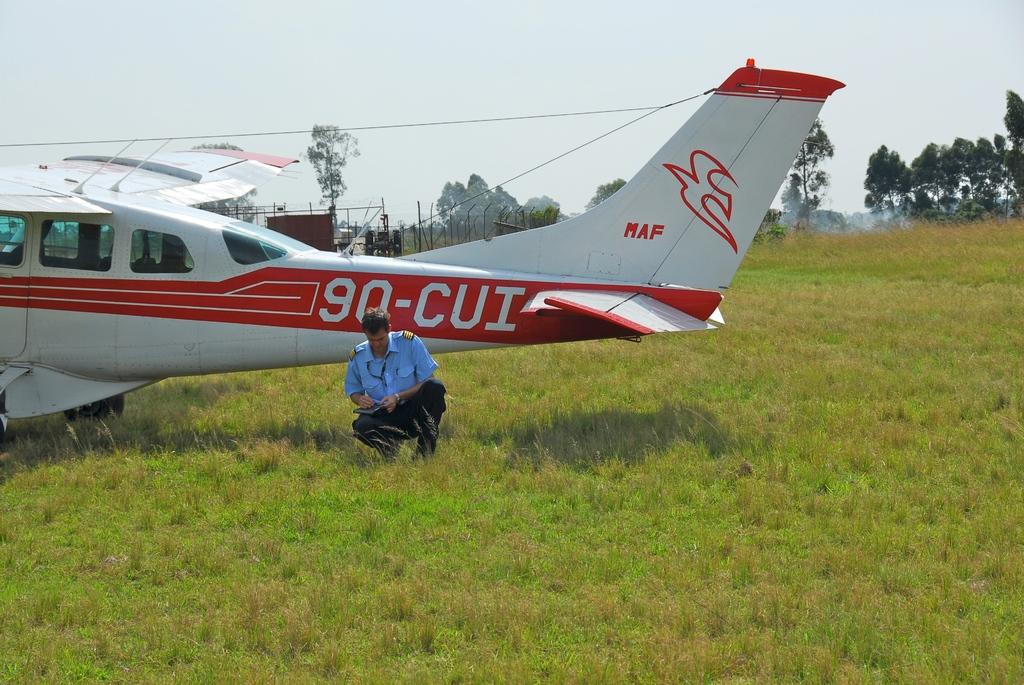What are the big numbers and letters written on the plane?
Ensure brevity in your answer.  90-cui. What is the code written on the tail wing?
Give a very brief answer. 90-cui. 